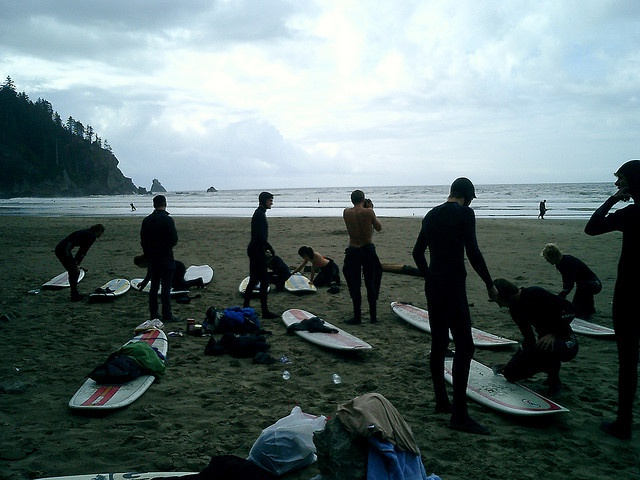Describe the objects in this image and their specific colors. I can see people in darkgray, black, gray, and darkgreen tones, people in darkgray, black, teal, and gray tones, people in darkgray, black, darkgreen, and teal tones, people in darkgray, black, and gray tones, and people in darkgray, black, and gray tones in this image. 